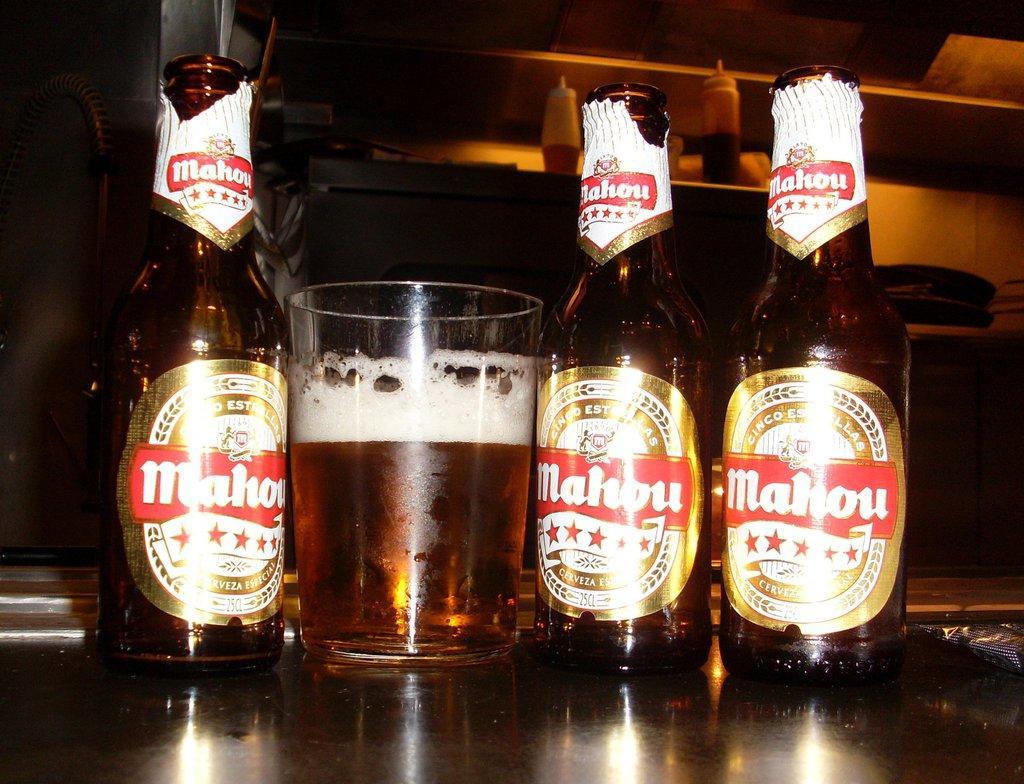Describe this image in one or two sentences. In this picture there are three bottles and a glass on a table. Background of the bottles is a shelf with some plastic bottles. 